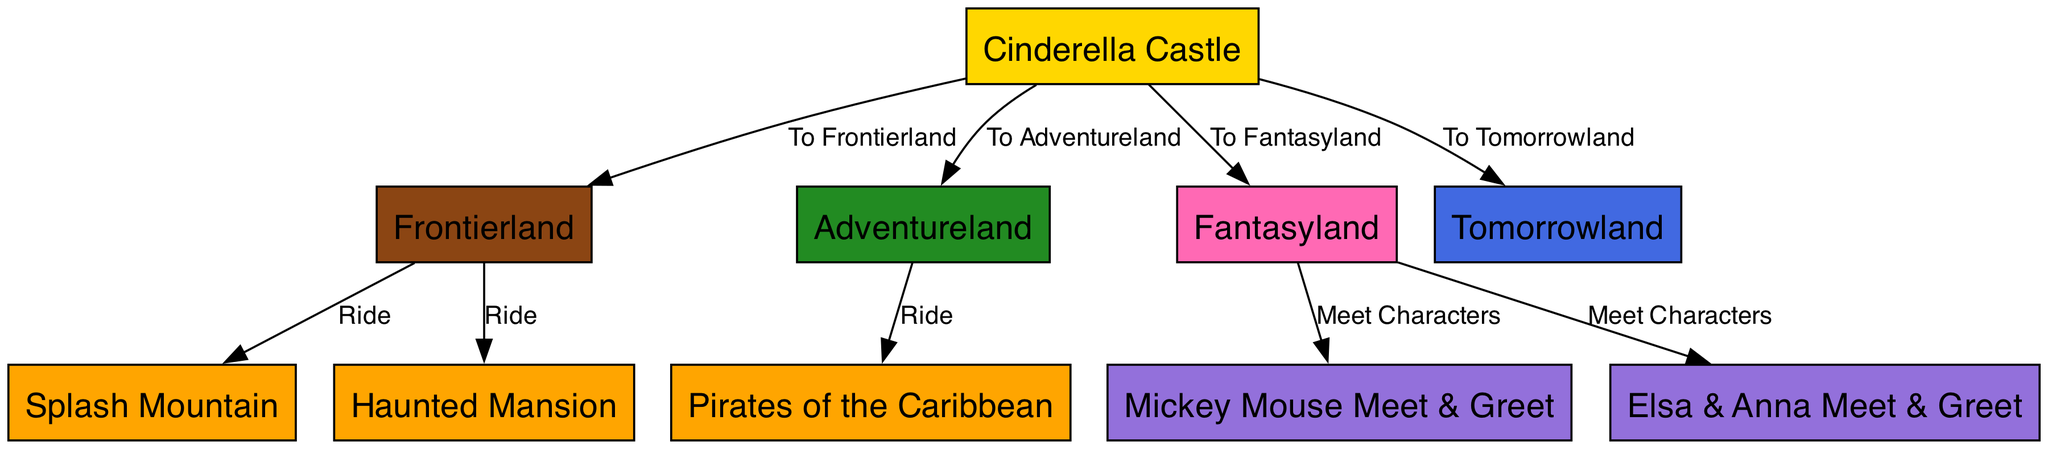What is the central feature of the map? The central feature of the map is the Cinderella Castle, as it is the starting point from which all other locations branch out.
Answer: Cinderella Castle How many ride locations are there in total? Count each ride listed in the diagram, which includes Splash Mountain, Pirates of the Caribbean, and Haunted Mansion, making a total of three rides.
Answer: 3 What is the color associated with Fantasyland? According to the color scheme in the diagram, Fantasyland is represented by the color hot pink.
Answer: HotPink Which location connects directly to Pirates of the Caribbean? Looking at the edges in the diagram, Pirates of the Caribbean is reached directly from Adventureland.
Answer: Adventureland Name one character meet-and-greet location. By examining the nodes specifically for meet-and-greet spots, we find the "Elsa & Anna Meet & Greet" as one of the locations.
Answer: Elsa & Anna Meet & Greet Which two locations are connected directly to the Cinderella Castle? The edges from the Cinderella Castle show direct connections to Frontierland and Adventureland.
Answer: Frontierland and Adventureland How many character meet-and-greet spots are shown? There are two character meet-and-greet spots illustrated on the diagram: one for Mickey Mouse and the other for Elsa & Anna.
Answer: 2 What rides can be accessed from Frontierland? The edges indicate that from Frontierland, you can visit both Splash Mountain and the Haunted Mansion.
Answer: Splash Mountain and Haunted Mansion Which area leads to Tomorrowland? The connection from the Cinderella Castle indicates that it leads directly to Tomorrowland.
Answer: Tomorrowland 